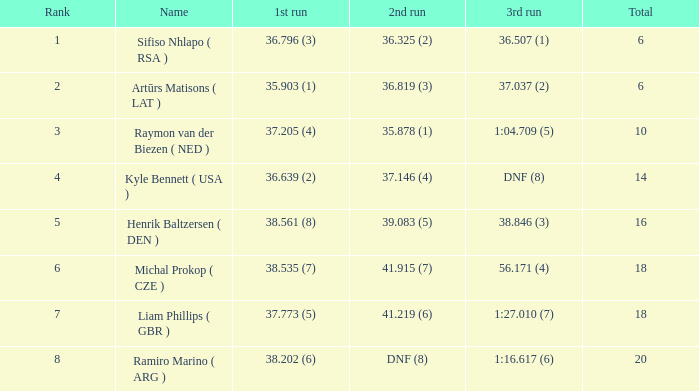Which average rating amounts to a total of 16? 5.0. 